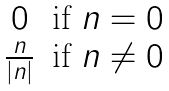<formula> <loc_0><loc_0><loc_500><loc_500>\begin{matrix} 0 & \text {if $n=0$} \\ \frac { n } { | n | } & \text {if $n\neq 0$} \end{matrix}</formula> 